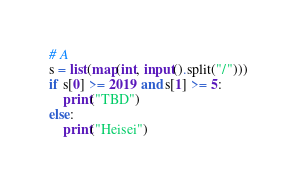<code> <loc_0><loc_0><loc_500><loc_500><_Python_># A
s = list(map(int, input().split("/")))
if s[0] >= 2019 and s[1] >= 5:
    print("TBD")
else:
    print("Heisei")
</code> 